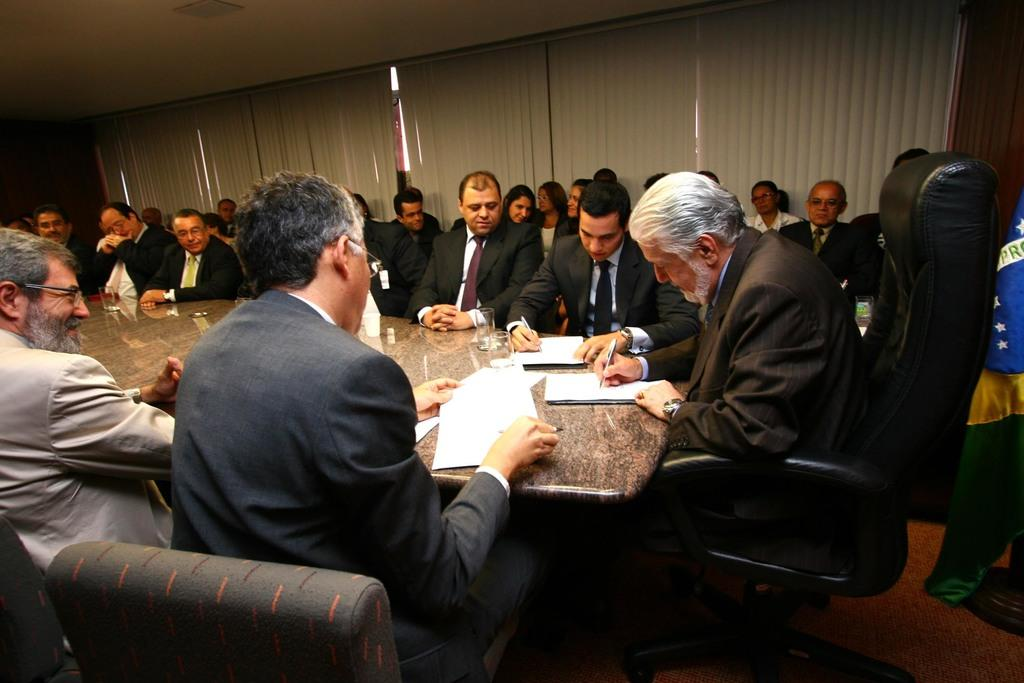What is happening in the image involving the people and the table? There are people surrounding a table, which suggests they might be participating in an activity or event. Can you describe the position of the person on the right side of the table? A person is sitting on a chair at the right side of the table. What is the person on the right side of the table holding? The person on the right is holding a pen in their hand. What can be seen in the right corner of the image? There is a flag in the right corner of the image. What type of cherry is being used as a paperweight on the table? There is no cherry present in the image, and therefore no such object is being used as a paperweight. 